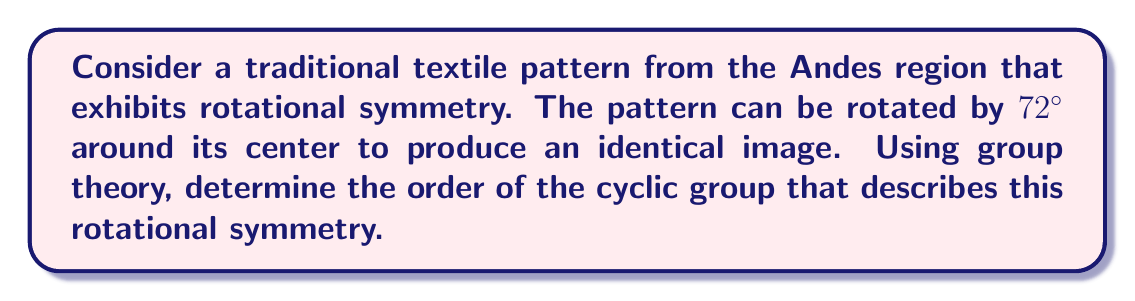Teach me how to tackle this problem. To solve this problem, we'll follow these steps:

1) First, we need to understand what rotational symmetry means in terms of group theory. A rotational symmetry corresponds to a cyclic group, where each element of the group represents a rotation that leaves the pattern unchanged.

2) The order of the cyclic group is the number of distinct rotations (including the identity rotation) that leave the pattern unchanged.

3) We're told that a rotation of 72° produces an identical image. Let's call this rotation $R$. We need to determine how many times we need to apply $R$ to get back to the identity rotation (360° or 0°).

4) Mathematically, we're looking for the smallest positive integer $n$ such that:

   $$R^n = I$$

   where $I$ is the identity rotation.

5) We can calculate this by dividing 360° by the angle of rotation:

   $$n = \frac{360°}{72°} = 5$$

6) This means that after 5 rotations of 72°, we get back to the starting position:

   $$72° \cdot 5 = 360°$$

7) Therefore, the cyclic group that describes this rotational symmetry has 5 elements:
   $\{I, R, R^2, R^3, R^4\}$

8) In group theory terminology, this is the cyclic group of order 5, often denoted as $C_5$ or $\mathbb{Z}_5$.
Answer: 5 